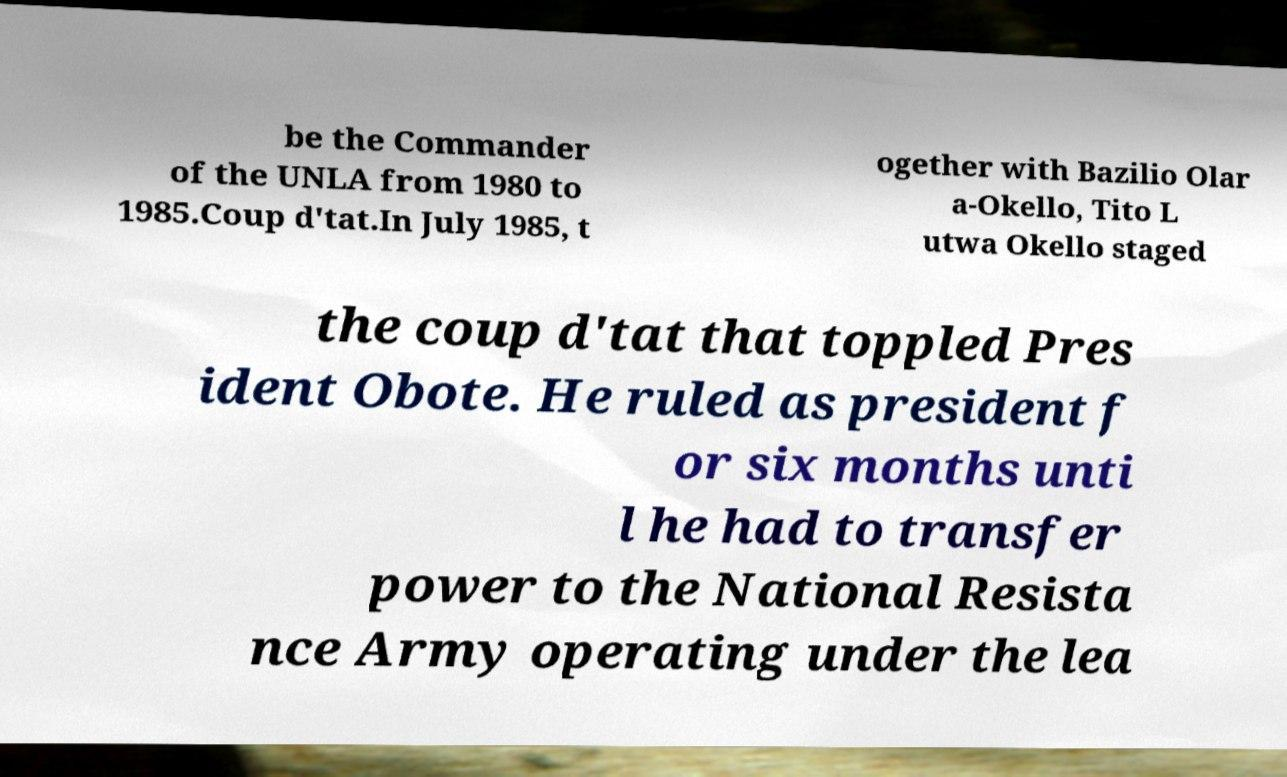Please read and relay the text visible in this image. What does it say? be the Commander of the UNLA from 1980 to 1985.Coup d'tat.In July 1985, t ogether with Bazilio Olar a-Okello, Tito L utwa Okello staged the coup d'tat that toppled Pres ident Obote. He ruled as president f or six months unti l he had to transfer power to the National Resista nce Army operating under the lea 